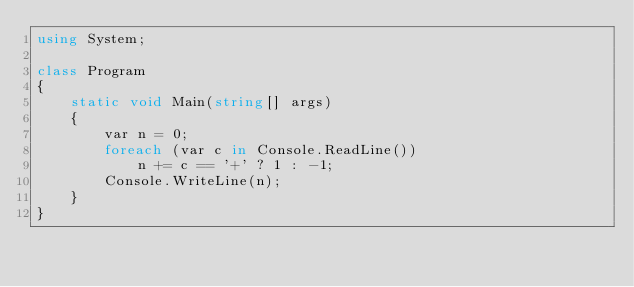Convert code to text. <code><loc_0><loc_0><loc_500><loc_500><_C#_>using System;

class Program
{
    static void Main(string[] args)
    {
        var n = 0;
        foreach (var c in Console.ReadLine())
            n += c == '+' ? 1 : -1;
        Console.WriteLine(n);
    }
}
</code> 